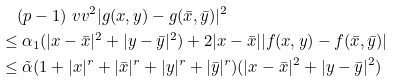Convert formula to latex. <formula><loc_0><loc_0><loc_500><loc_500>& \quad ( p - 1 ) \ v v ^ { 2 } | g ( x , y ) - g ( \bar { x } , \bar { y } ) | ^ { 2 } \\ & \leq \alpha _ { 1 } ( | x - \bar { x } | ^ { 2 } + | y - \bar { y } | ^ { 2 } ) + 2 | x - \bar { x } | | f ( x , y ) - f ( \bar { x } , \bar { y } ) | \\ & \leq \tilde { \alpha } ( 1 + | x | ^ { r } + | \bar { x } | ^ { r } + | y | ^ { r } + | \bar { y } | ^ { r } ) ( | x - \bar { x } | ^ { 2 } + | y - \bar { y } | ^ { 2 } )</formula> 